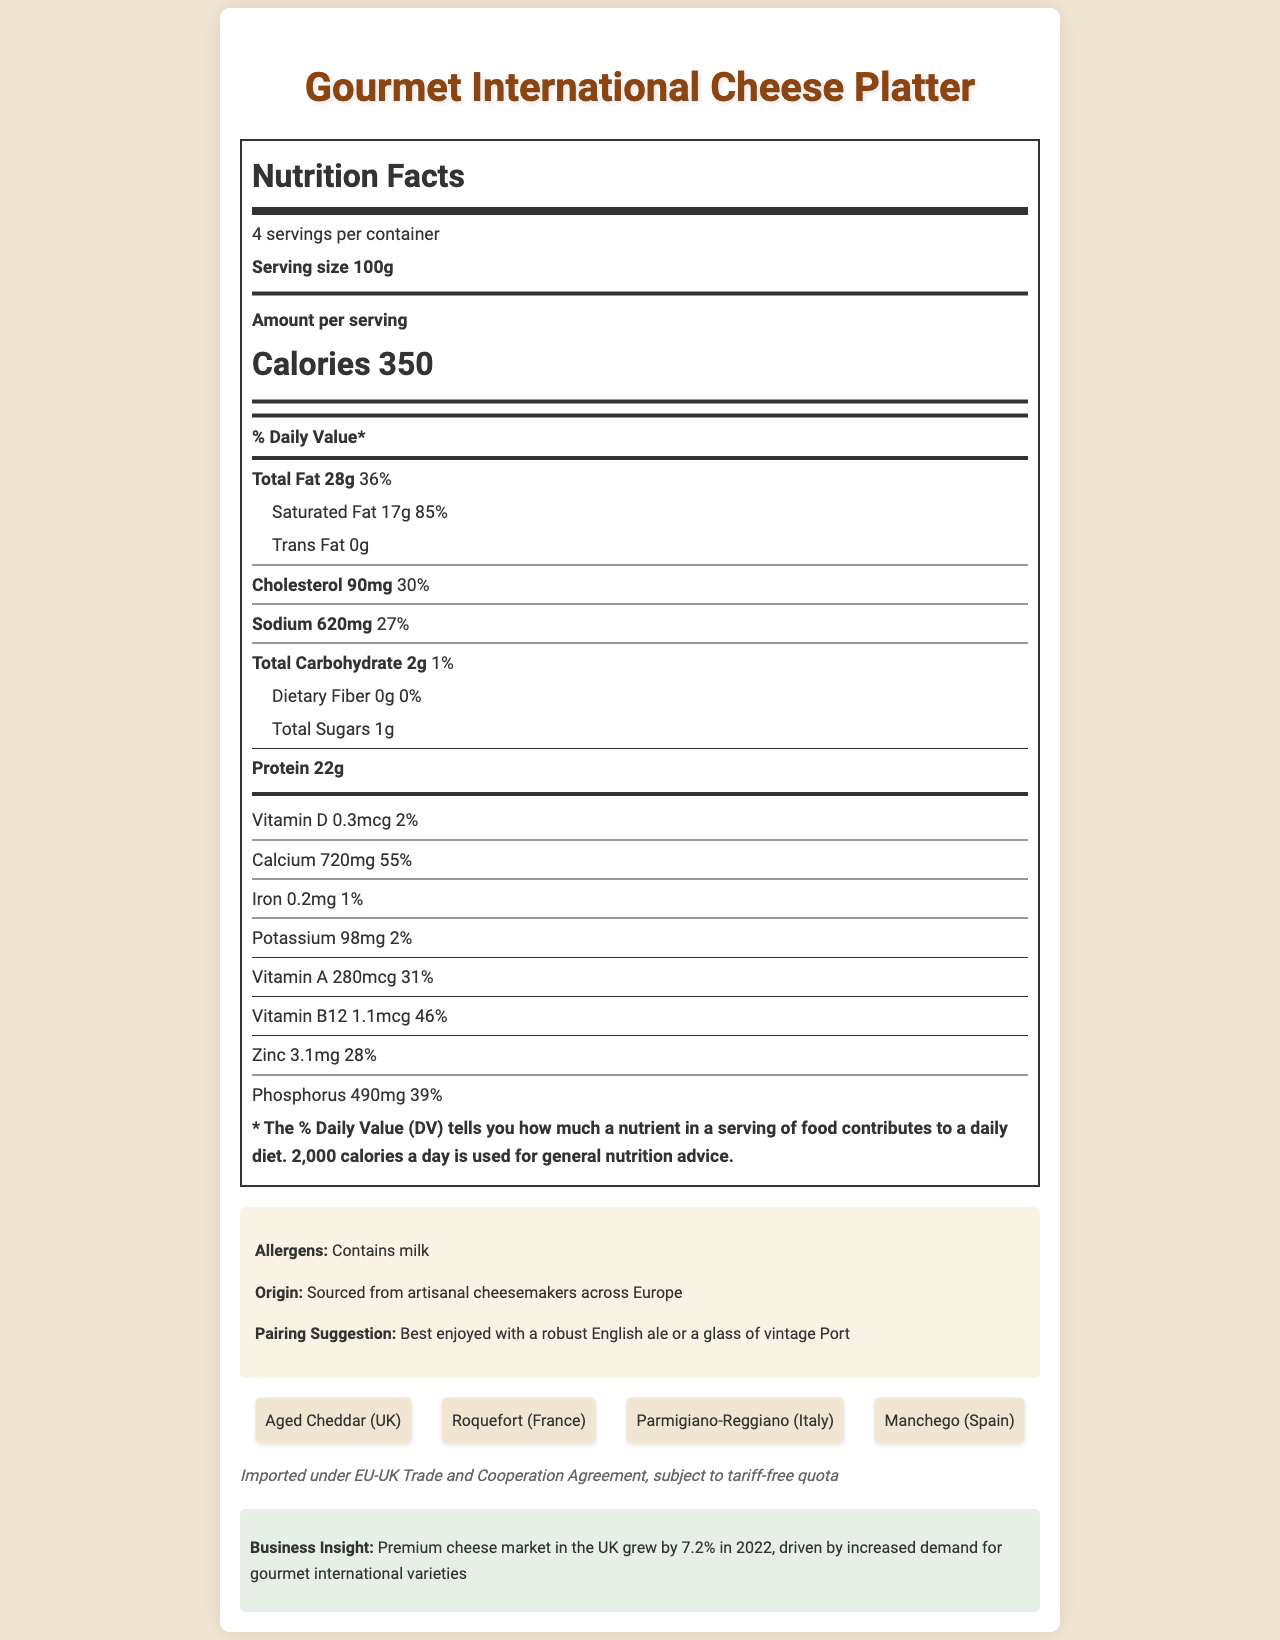what is the serving size of the Gourmet International Cheese Platter? The first section of the nutrition label specifies that the serving size is 100g.
Answer: 100g how many servings per container does the cheese platter have? The nutrition label indicates that there are 4 servings per container.
Answer: 4 how many calories are in one serving of the cheese platter? The label shows that each serving contains 350 calories.
Answer: 350 what is the percentage of the daily value for saturated fat per serving? Under the 'Total Fat' section, the amount and daily value percentage for saturated fat are listed as 17g and 85%, respectively.
Answer: 85% name the cheese varieties included in the platter. This information is provided in the cheese varieties section towards the end of the document.
Answer: Aged Cheddar (UK), Roquefort (France), Parmigiano-Reggiano (Italy), Manchego (Spain) what is the calcium content per serving of the cheese platter? The nutrition label lists the calcium content as 720mg.
Answer: 720mg what percentage of the daily value of vitamin B12 does one serving provide? The label indicates that each serving provides 46% of the daily value for vitamin B12.
Answer: 46% which of the following vitamins has the smallest daily value percentage in the cheese platter? A. Vitamin D B. Vitamin A C. Vitamin B12 The vitamin D daily value is 2%, which is smaller than the daily values for vitamin A (31%) and vitamin B12 (46%).
Answer: A. Vitamin D how much protein is in one serving? The protein section of the nutrition label indicates that one serving contains 22g of protein.
Answer: 22g what is the origin statement for the cheese platter? A. Made in the UK B. Sourced from artisanal cheesemakers across Europe C. Imported from the US The origin statement specifies that the product is sourced from artisanal cheesemakers across Europe.
Answer: B. Sourced from artisanal cheesemakers across Europe is the cheese platter free of trans fat? The label indicates that the platter contains 0g of trans fat.
Answer: Yes summarize the nutrition facts label for the Gourmet International Cheese Platter. This brief overview captures all the key elements in the nutrition facts label and the supplementary information sections.
Answer: The document outlines the nutritional details of the Gourmet International Cheese Platter with a serving size of 100g and four servings per container. It provides comprehensive data on calories, total fat, saturated fat, cholesterol, sodium, carbohydrates, protein, and essential vitamins and minerals like calcium and vitamin B12. Additional information includes cheese varieties, allergens, origin, pairing suggestions, trade notes, and insights on the premium cheese market growth. what is the phosphorus content in one serving of the cheese platter? The nutrition label indicates that each serving contains 490mg of phosphorus.
Answer: 490mg what type of import agreement is mentioned in the document? The document mentions that the product is imported under the EU-UK Trade and Cooperation Agreement.
Answer: EU-UK Trade and Cooperation Agreement how many grams of total fat does one serving contain? The nutrition label specifies that there are 28 grams of total fat per serving.
Answer: 28g which type of beverage is suggested as a pairing for the cheese platter? A. English ale B. White wine C. Whiskey D. Vodka The pairing suggestion notes that the cheese platter is best enjoyed with a robust English ale or a glass of vintage Port.
Answer: A. English ale how has the premium cheese market grown in the UK in 2022? The business insight section at the bottom states that the premium cheese market in the UK grew by 7.2% in 2022.
Answer: 7.2% which vitamin D amount is higher? A. The amount in one serving of the cheese platter B. None, they are the same Each serving of the cheese platter contains 0.3mcg of vitamin D as indicated in the nutrition label.
Answer: B. None, they are the same are there any dietary fibers in the cheese platter? The nutrition label specifies that there are 0g of dietary fiber per serving.
Answer: No what is the total weight of the cheese platter (assuming all servings are of equal size)? With a serving size of 100g and 4 servings per container, the total weight is 100g x 4 = 400g.
Answer: 400g what are the health benefits of this cheese platter? The document provides detailed nutritional information but does not discuss specific health benefits, so this cannot be determined based on the provided data.
Answer: Not enough information 